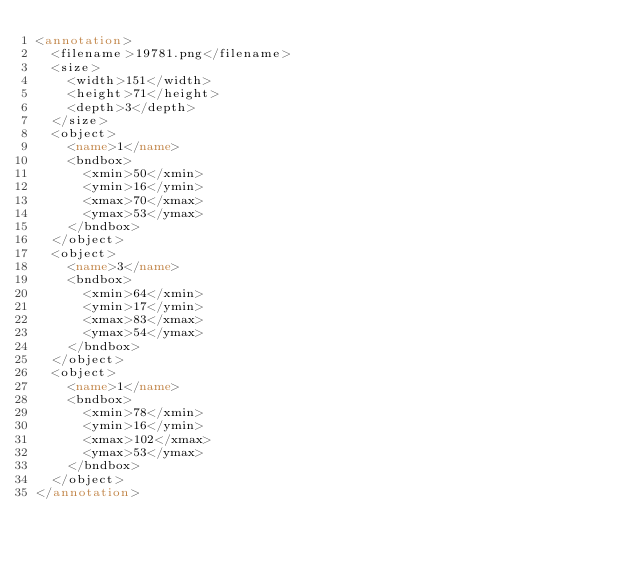<code> <loc_0><loc_0><loc_500><loc_500><_XML_><annotation>
  <filename>19781.png</filename>
  <size>
    <width>151</width>
    <height>71</height>
    <depth>3</depth>
  </size>
  <object>
    <name>1</name>
    <bndbox>
      <xmin>50</xmin>
      <ymin>16</ymin>
      <xmax>70</xmax>
      <ymax>53</ymax>
    </bndbox>
  </object>
  <object>
    <name>3</name>
    <bndbox>
      <xmin>64</xmin>
      <ymin>17</ymin>
      <xmax>83</xmax>
      <ymax>54</ymax>
    </bndbox>
  </object>
  <object>
    <name>1</name>
    <bndbox>
      <xmin>78</xmin>
      <ymin>16</ymin>
      <xmax>102</xmax>
      <ymax>53</ymax>
    </bndbox>
  </object>
</annotation>
</code> 